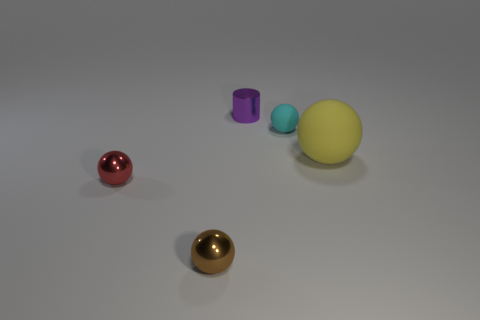Subtract all yellow spheres. How many spheres are left? 3 Add 5 big purple metal things. How many objects exist? 10 Subtract all cylinders. How many objects are left? 4 Subtract all cyan rubber balls. Subtract all spheres. How many objects are left? 0 Add 5 brown spheres. How many brown spheres are left? 6 Add 5 yellow matte objects. How many yellow matte objects exist? 6 Subtract 0 gray cylinders. How many objects are left? 5 